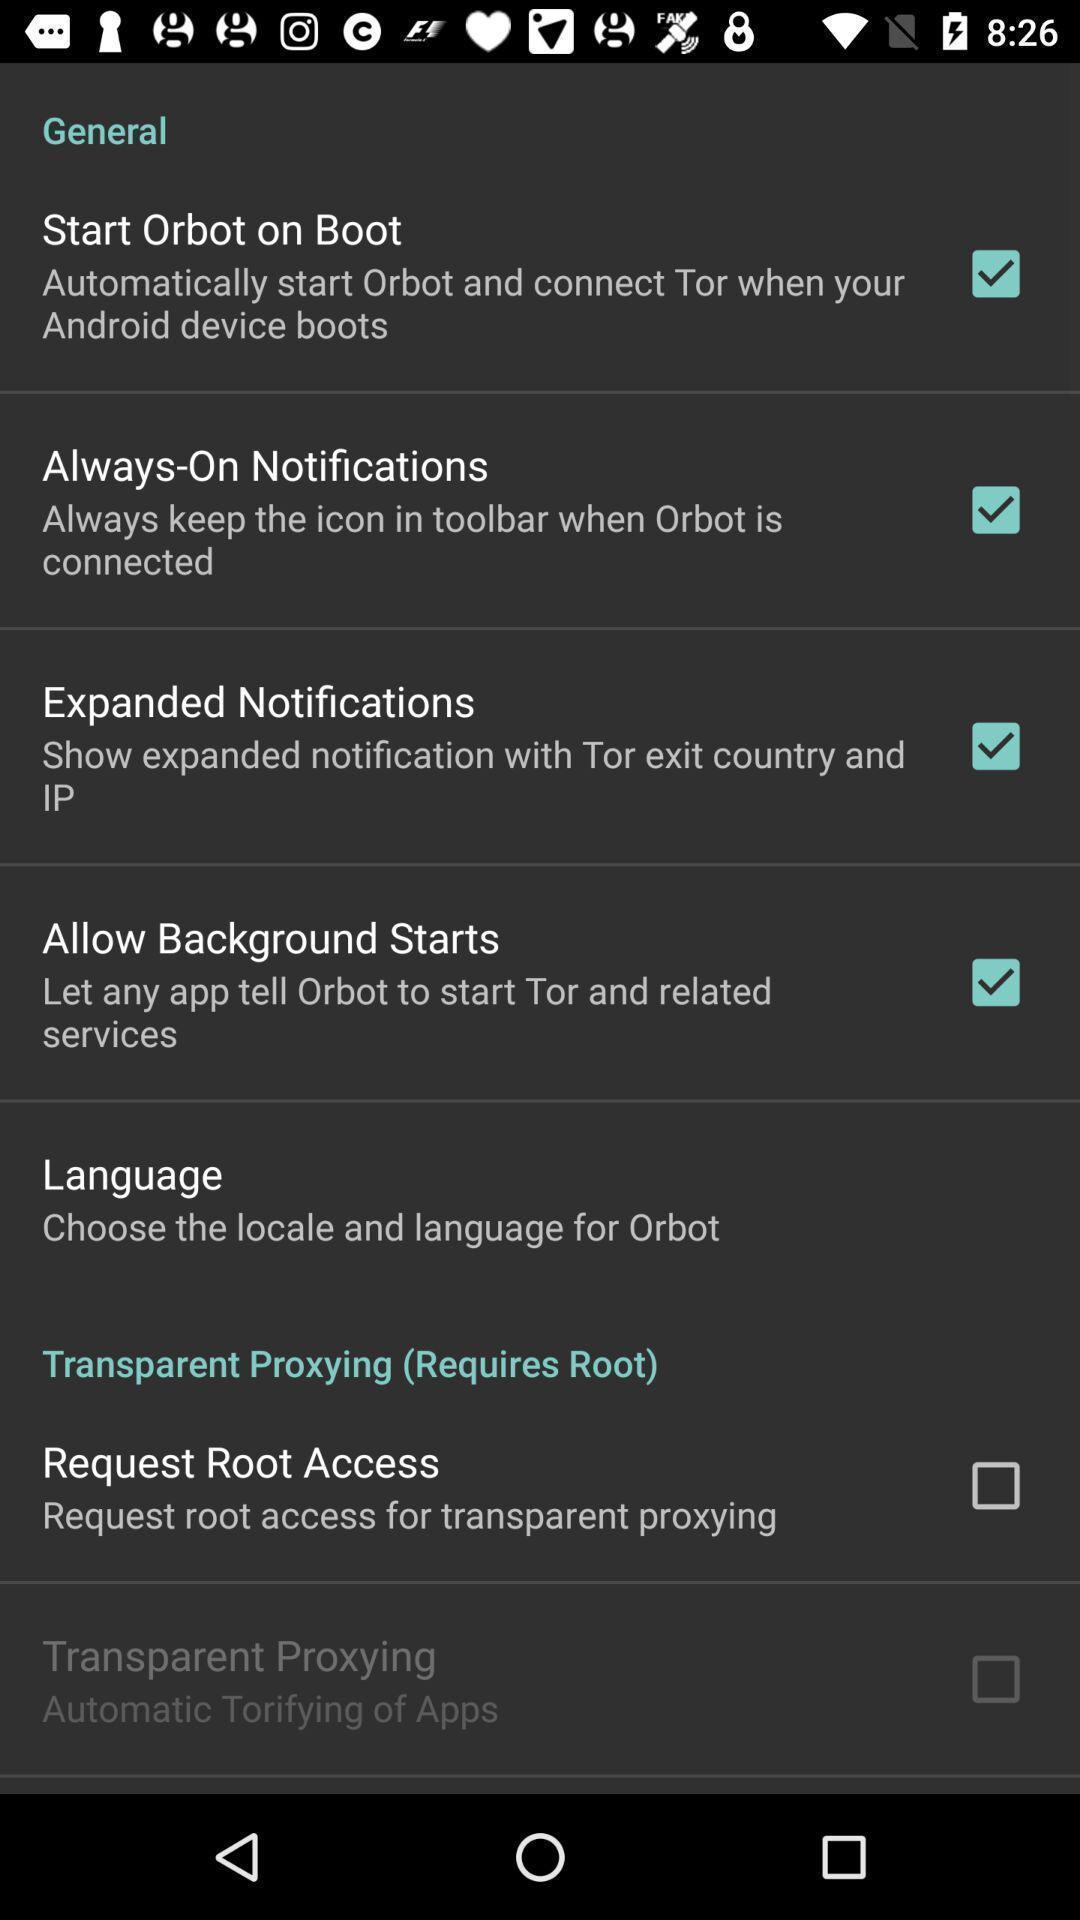Give me a summary of this screen capture. Screen shows multiple options. 